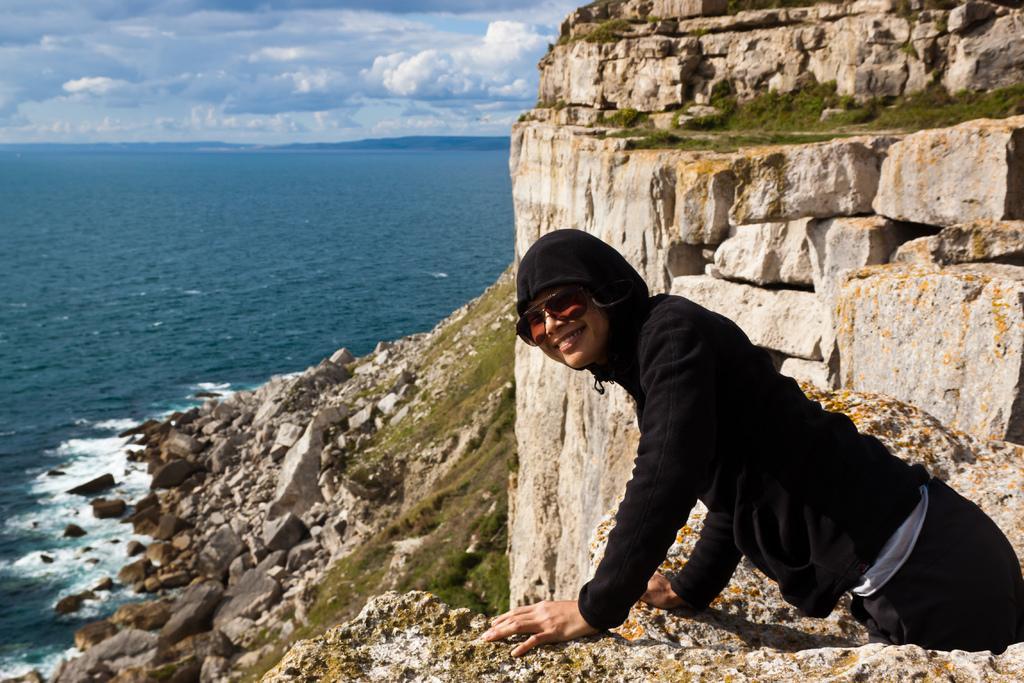How would you summarize this image in a sentence or two? On the right side of the image there is a person standing. On the left side of the image there is a river. In the background there is a sky. 